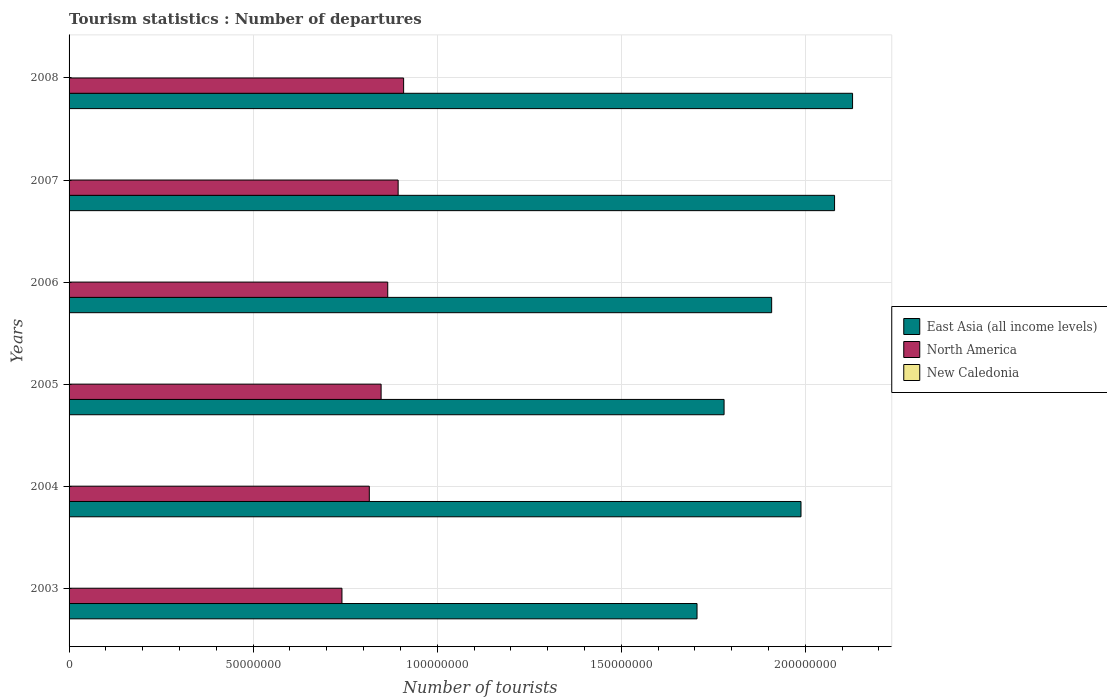How many different coloured bars are there?
Ensure brevity in your answer.  3. What is the label of the 5th group of bars from the top?
Offer a very short reply. 2004. In how many cases, is the number of bars for a given year not equal to the number of legend labels?
Provide a succinct answer. 0. What is the number of tourist departures in New Caledonia in 2004?
Ensure brevity in your answer.  8.90e+04. Across all years, what is the maximum number of tourist departures in New Caledonia?
Your answer should be compact. 1.12e+05. Across all years, what is the minimum number of tourist departures in North America?
Provide a short and direct response. 7.41e+07. What is the total number of tourist departures in North America in the graph?
Keep it short and to the point. 5.07e+08. What is the difference between the number of tourist departures in North America in 2005 and that in 2008?
Provide a short and direct response. -6.12e+06. What is the difference between the number of tourist departures in New Caledonia in 2004 and the number of tourist departures in East Asia (all income levels) in 2008?
Your answer should be very brief. -2.13e+08. What is the average number of tourist departures in New Caledonia per year?
Offer a terse response. 9.68e+04. In the year 2003, what is the difference between the number of tourist departures in East Asia (all income levels) and number of tourist departures in New Caledonia?
Provide a succinct answer. 1.71e+08. What is the ratio of the number of tourist departures in East Asia (all income levels) in 2003 to that in 2006?
Keep it short and to the point. 0.89. Is the difference between the number of tourist departures in East Asia (all income levels) in 2004 and 2008 greater than the difference between the number of tourist departures in New Caledonia in 2004 and 2008?
Offer a terse response. No. What is the difference between the highest and the second highest number of tourist departures in North America?
Provide a short and direct response. 1.49e+06. What is the difference between the highest and the lowest number of tourist departures in East Asia (all income levels)?
Keep it short and to the point. 4.23e+07. What does the 1st bar from the top in 2006 represents?
Offer a very short reply. New Caledonia. What does the 3rd bar from the bottom in 2008 represents?
Your response must be concise. New Caledonia. How many bars are there?
Provide a short and direct response. 18. Are the values on the major ticks of X-axis written in scientific E-notation?
Make the answer very short. No. Does the graph contain any zero values?
Provide a short and direct response. No. Does the graph contain grids?
Offer a very short reply. Yes. How are the legend labels stacked?
Your answer should be compact. Vertical. What is the title of the graph?
Ensure brevity in your answer.  Tourism statistics : Number of departures. What is the label or title of the X-axis?
Make the answer very short. Number of tourists. What is the label or title of the Y-axis?
Make the answer very short. Years. What is the Number of tourists of East Asia (all income levels) in 2003?
Your answer should be very brief. 1.71e+08. What is the Number of tourists of North America in 2003?
Your answer should be compact. 7.41e+07. What is the Number of tourists in New Caledonia in 2003?
Provide a succinct answer. 7.80e+04. What is the Number of tourists in East Asia (all income levels) in 2004?
Offer a terse response. 1.99e+08. What is the Number of tourists of North America in 2004?
Provide a short and direct response. 8.16e+07. What is the Number of tourists of New Caledonia in 2004?
Ensure brevity in your answer.  8.90e+04. What is the Number of tourists of East Asia (all income levels) in 2005?
Keep it short and to the point. 1.78e+08. What is the Number of tourists of North America in 2005?
Provide a succinct answer. 8.48e+07. What is the Number of tourists in New Caledonia in 2005?
Provide a short and direct response. 9.60e+04. What is the Number of tourists of East Asia (all income levels) in 2006?
Your response must be concise. 1.91e+08. What is the Number of tourists of North America in 2006?
Your response must be concise. 8.66e+07. What is the Number of tourists in East Asia (all income levels) in 2007?
Offer a very short reply. 2.08e+08. What is the Number of tourists in North America in 2007?
Provide a short and direct response. 8.94e+07. What is the Number of tourists in New Caledonia in 2007?
Ensure brevity in your answer.  1.06e+05. What is the Number of tourists of East Asia (all income levels) in 2008?
Make the answer very short. 2.13e+08. What is the Number of tourists of North America in 2008?
Offer a terse response. 9.09e+07. What is the Number of tourists in New Caledonia in 2008?
Provide a succinct answer. 1.12e+05. Across all years, what is the maximum Number of tourists of East Asia (all income levels)?
Provide a short and direct response. 2.13e+08. Across all years, what is the maximum Number of tourists of North America?
Your response must be concise. 9.09e+07. Across all years, what is the maximum Number of tourists in New Caledonia?
Your response must be concise. 1.12e+05. Across all years, what is the minimum Number of tourists in East Asia (all income levels)?
Keep it short and to the point. 1.71e+08. Across all years, what is the minimum Number of tourists of North America?
Provide a succinct answer. 7.41e+07. Across all years, what is the minimum Number of tourists in New Caledonia?
Provide a short and direct response. 7.80e+04. What is the total Number of tourists of East Asia (all income levels) in the graph?
Your answer should be compact. 1.16e+09. What is the total Number of tourists in North America in the graph?
Your answer should be very brief. 5.07e+08. What is the total Number of tourists of New Caledonia in the graph?
Keep it short and to the point. 5.81e+05. What is the difference between the Number of tourists of East Asia (all income levels) in 2003 and that in 2004?
Provide a short and direct response. -2.82e+07. What is the difference between the Number of tourists of North America in 2003 and that in 2004?
Offer a terse response. -7.43e+06. What is the difference between the Number of tourists of New Caledonia in 2003 and that in 2004?
Provide a short and direct response. -1.10e+04. What is the difference between the Number of tourists of East Asia (all income levels) in 2003 and that in 2005?
Your answer should be very brief. -7.35e+06. What is the difference between the Number of tourists of North America in 2003 and that in 2005?
Provide a short and direct response. -1.06e+07. What is the difference between the Number of tourists of New Caledonia in 2003 and that in 2005?
Offer a terse response. -1.80e+04. What is the difference between the Number of tourists of East Asia (all income levels) in 2003 and that in 2006?
Keep it short and to the point. -2.03e+07. What is the difference between the Number of tourists of North America in 2003 and that in 2006?
Keep it short and to the point. -1.24e+07. What is the difference between the Number of tourists in New Caledonia in 2003 and that in 2006?
Ensure brevity in your answer.  -2.20e+04. What is the difference between the Number of tourists in East Asia (all income levels) in 2003 and that in 2007?
Your answer should be very brief. -3.74e+07. What is the difference between the Number of tourists in North America in 2003 and that in 2007?
Offer a terse response. -1.53e+07. What is the difference between the Number of tourists of New Caledonia in 2003 and that in 2007?
Keep it short and to the point. -2.80e+04. What is the difference between the Number of tourists of East Asia (all income levels) in 2003 and that in 2008?
Offer a very short reply. -4.23e+07. What is the difference between the Number of tourists in North America in 2003 and that in 2008?
Offer a terse response. -1.67e+07. What is the difference between the Number of tourists of New Caledonia in 2003 and that in 2008?
Your response must be concise. -3.40e+04. What is the difference between the Number of tourists of East Asia (all income levels) in 2004 and that in 2005?
Offer a very short reply. 2.09e+07. What is the difference between the Number of tourists in North America in 2004 and that in 2005?
Your response must be concise. -3.20e+06. What is the difference between the Number of tourists in New Caledonia in 2004 and that in 2005?
Make the answer very short. -7000. What is the difference between the Number of tourists of East Asia (all income levels) in 2004 and that in 2006?
Give a very brief answer. 7.97e+06. What is the difference between the Number of tourists in North America in 2004 and that in 2006?
Your answer should be compact. -5.00e+06. What is the difference between the Number of tourists in New Caledonia in 2004 and that in 2006?
Give a very brief answer. -1.10e+04. What is the difference between the Number of tourists in East Asia (all income levels) in 2004 and that in 2007?
Your answer should be compact. -9.12e+06. What is the difference between the Number of tourists in North America in 2004 and that in 2007?
Ensure brevity in your answer.  -7.83e+06. What is the difference between the Number of tourists of New Caledonia in 2004 and that in 2007?
Make the answer very short. -1.70e+04. What is the difference between the Number of tourists in East Asia (all income levels) in 2004 and that in 2008?
Offer a very short reply. -1.40e+07. What is the difference between the Number of tourists in North America in 2004 and that in 2008?
Give a very brief answer. -9.32e+06. What is the difference between the Number of tourists of New Caledonia in 2004 and that in 2008?
Make the answer very short. -2.30e+04. What is the difference between the Number of tourists of East Asia (all income levels) in 2005 and that in 2006?
Provide a succinct answer. -1.29e+07. What is the difference between the Number of tourists in North America in 2005 and that in 2006?
Ensure brevity in your answer.  -1.80e+06. What is the difference between the Number of tourists in New Caledonia in 2005 and that in 2006?
Ensure brevity in your answer.  -4000. What is the difference between the Number of tourists of East Asia (all income levels) in 2005 and that in 2007?
Make the answer very short. -3.00e+07. What is the difference between the Number of tourists in North America in 2005 and that in 2007?
Your response must be concise. -4.63e+06. What is the difference between the Number of tourists of New Caledonia in 2005 and that in 2007?
Ensure brevity in your answer.  -10000. What is the difference between the Number of tourists of East Asia (all income levels) in 2005 and that in 2008?
Give a very brief answer. -3.49e+07. What is the difference between the Number of tourists in North America in 2005 and that in 2008?
Your response must be concise. -6.12e+06. What is the difference between the Number of tourists of New Caledonia in 2005 and that in 2008?
Provide a short and direct response. -1.60e+04. What is the difference between the Number of tourists of East Asia (all income levels) in 2006 and that in 2007?
Keep it short and to the point. -1.71e+07. What is the difference between the Number of tourists of North America in 2006 and that in 2007?
Make the answer very short. -2.83e+06. What is the difference between the Number of tourists in New Caledonia in 2006 and that in 2007?
Provide a succinct answer. -6000. What is the difference between the Number of tourists of East Asia (all income levels) in 2006 and that in 2008?
Give a very brief answer. -2.20e+07. What is the difference between the Number of tourists in North America in 2006 and that in 2008?
Provide a succinct answer. -4.32e+06. What is the difference between the Number of tourists of New Caledonia in 2006 and that in 2008?
Offer a terse response. -1.20e+04. What is the difference between the Number of tourists of East Asia (all income levels) in 2007 and that in 2008?
Offer a very short reply. -4.89e+06. What is the difference between the Number of tourists of North America in 2007 and that in 2008?
Keep it short and to the point. -1.49e+06. What is the difference between the Number of tourists of New Caledonia in 2007 and that in 2008?
Your response must be concise. -6000. What is the difference between the Number of tourists in East Asia (all income levels) in 2003 and the Number of tourists in North America in 2004?
Ensure brevity in your answer.  8.90e+07. What is the difference between the Number of tourists of East Asia (all income levels) in 2003 and the Number of tourists of New Caledonia in 2004?
Give a very brief answer. 1.70e+08. What is the difference between the Number of tourists in North America in 2003 and the Number of tourists in New Caledonia in 2004?
Provide a short and direct response. 7.40e+07. What is the difference between the Number of tourists of East Asia (all income levels) in 2003 and the Number of tourists of North America in 2005?
Your answer should be compact. 8.58e+07. What is the difference between the Number of tourists in East Asia (all income levels) in 2003 and the Number of tourists in New Caledonia in 2005?
Ensure brevity in your answer.  1.70e+08. What is the difference between the Number of tourists of North America in 2003 and the Number of tourists of New Caledonia in 2005?
Provide a succinct answer. 7.40e+07. What is the difference between the Number of tourists of East Asia (all income levels) in 2003 and the Number of tourists of North America in 2006?
Provide a succinct answer. 8.40e+07. What is the difference between the Number of tourists of East Asia (all income levels) in 2003 and the Number of tourists of New Caledonia in 2006?
Your response must be concise. 1.70e+08. What is the difference between the Number of tourists in North America in 2003 and the Number of tourists in New Caledonia in 2006?
Give a very brief answer. 7.40e+07. What is the difference between the Number of tourists in East Asia (all income levels) in 2003 and the Number of tourists in North America in 2007?
Offer a very short reply. 8.12e+07. What is the difference between the Number of tourists in East Asia (all income levels) in 2003 and the Number of tourists in New Caledonia in 2007?
Keep it short and to the point. 1.70e+08. What is the difference between the Number of tourists of North America in 2003 and the Number of tourists of New Caledonia in 2007?
Offer a very short reply. 7.40e+07. What is the difference between the Number of tourists of East Asia (all income levels) in 2003 and the Number of tourists of North America in 2008?
Give a very brief answer. 7.97e+07. What is the difference between the Number of tourists in East Asia (all income levels) in 2003 and the Number of tourists in New Caledonia in 2008?
Keep it short and to the point. 1.70e+08. What is the difference between the Number of tourists of North America in 2003 and the Number of tourists of New Caledonia in 2008?
Provide a short and direct response. 7.40e+07. What is the difference between the Number of tourists of East Asia (all income levels) in 2004 and the Number of tourists of North America in 2005?
Keep it short and to the point. 1.14e+08. What is the difference between the Number of tourists of East Asia (all income levels) in 2004 and the Number of tourists of New Caledonia in 2005?
Your answer should be very brief. 1.99e+08. What is the difference between the Number of tourists in North America in 2004 and the Number of tourists in New Caledonia in 2005?
Your answer should be very brief. 8.15e+07. What is the difference between the Number of tourists of East Asia (all income levels) in 2004 and the Number of tourists of North America in 2006?
Provide a succinct answer. 1.12e+08. What is the difference between the Number of tourists of East Asia (all income levels) in 2004 and the Number of tourists of New Caledonia in 2006?
Provide a short and direct response. 1.99e+08. What is the difference between the Number of tourists of North America in 2004 and the Number of tourists of New Caledonia in 2006?
Your response must be concise. 8.15e+07. What is the difference between the Number of tourists of East Asia (all income levels) in 2004 and the Number of tourists of North America in 2007?
Offer a terse response. 1.09e+08. What is the difference between the Number of tourists of East Asia (all income levels) in 2004 and the Number of tourists of New Caledonia in 2007?
Make the answer very short. 1.99e+08. What is the difference between the Number of tourists of North America in 2004 and the Number of tourists of New Caledonia in 2007?
Your answer should be compact. 8.15e+07. What is the difference between the Number of tourists of East Asia (all income levels) in 2004 and the Number of tourists of North America in 2008?
Your response must be concise. 1.08e+08. What is the difference between the Number of tourists in East Asia (all income levels) in 2004 and the Number of tourists in New Caledonia in 2008?
Your answer should be compact. 1.99e+08. What is the difference between the Number of tourists in North America in 2004 and the Number of tourists in New Caledonia in 2008?
Your answer should be very brief. 8.14e+07. What is the difference between the Number of tourists of East Asia (all income levels) in 2005 and the Number of tourists of North America in 2006?
Provide a succinct answer. 9.14e+07. What is the difference between the Number of tourists of East Asia (all income levels) in 2005 and the Number of tourists of New Caledonia in 2006?
Offer a terse response. 1.78e+08. What is the difference between the Number of tourists in North America in 2005 and the Number of tourists in New Caledonia in 2006?
Provide a short and direct response. 8.47e+07. What is the difference between the Number of tourists in East Asia (all income levels) in 2005 and the Number of tourists in North America in 2007?
Your answer should be compact. 8.85e+07. What is the difference between the Number of tourists of East Asia (all income levels) in 2005 and the Number of tourists of New Caledonia in 2007?
Give a very brief answer. 1.78e+08. What is the difference between the Number of tourists in North America in 2005 and the Number of tourists in New Caledonia in 2007?
Your response must be concise. 8.47e+07. What is the difference between the Number of tourists in East Asia (all income levels) in 2005 and the Number of tourists in North America in 2008?
Your response must be concise. 8.71e+07. What is the difference between the Number of tourists in East Asia (all income levels) in 2005 and the Number of tourists in New Caledonia in 2008?
Provide a succinct answer. 1.78e+08. What is the difference between the Number of tourists in North America in 2005 and the Number of tourists in New Caledonia in 2008?
Ensure brevity in your answer.  8.47e+07. What is the difference between the Number of tourists in East Asia (all income levels) in 2006 and the Number of tourists in North America in 2007?
Offer a terse response. 1.01e+08. What is the difference between the Number of tourists of East Asia (all income levels) in 2006 and the Number of tourists of New Caledonia in 2007?
Offer a terse response. 1.91e+08. What is the difference between the Number of tourists in North America in 2006 and the Number of tourists in New Caledonia in 2007?
Provide a succinct answer. 8.65e+07. What is the difference between the Number of tourists in East Asia (all income levels) in 2006 and the Number of tourists in North America in 2008?
Your answer should be compact. 1.00e+08. What is the difference between the Number of tourists of East Asia (all income levels) in 2006 and the Number of tourists of New Caledonia in 2008?
Make the answer very short. 1.91e+08. What is the difference between the Number of tourists of North America in 2006 and the Number of tourists of New Caledonia in 2008?
Offer a terse response. 8.65e+07. What is the difference between the Number of tourists of East Asia (all income levels) in 2007 and the Number of tourists of North America in 2008?
Your response must be concise. 1.17e+08. What is the difference between the Number of tourists in East Asia (all income levels) in 2007 and the Number of tourists in New Caledonia in 2008?
Provide a short and direct response. 2.08e+08. What is the difference between the Number of tourists in North America in 2007 and the Number of tourists in New Caledonia in 2008?
Offer a very short reply. 8.93e+07. What is the average Number of tourists in East Asia (all income levels) per year?
Offer a terse response. 1.93e+08. What is the average Number of tourists in North America per year?
Ensure brevity in your answer.  8.45e+07. What is the average Number of tourists in New Caledonia per year?
Your response must be concise. 9.68e+04. In the year 2003, what is the difference between the Number of tourists in East Asia (all income levels) and Number of tourists in North America?
Your response must be concise. 9.65e+07. In the year 2003, what is the difference between the Number of tourists in East Asia (all income levels) and Number of tourists in New Caledonia?
Your response must be concise. 1.71e+08. In the year 2003, what is the difference between the Number of tourists of North America and Number of tourists of New Caledonia?
Your answer should be very brief. 7.41e+07. In the year 2004, what is the difference between the Number of tourists in East Asia (all income levels) and Number of tourists in North America?
Offer a very short reply. 1.17e+08. In the year 2004, what is the difference between the Number of tourists in East Asia (all income levels) and Number of tourists in New Caledonia?
Offer a terse response. 1.99e+08. In the year 2004, what is the difference between the Number of tourists in North America and Number of tourists in New Caledonia?
Make the answer very short. 8.15e+07. In the year 2005, what is the difference between the Number of tourists of East Asia (all income levels) and Number of tourists of North America?
Offer a terse response. 9.32e+07. In the year 2005, what is the difference between the Number of tourists in East Asia (all income levels) and Number of tourists in New Caledonia?
Your answer should be very brief. 1.78e+08. In the year 2005, what is the difference between the Number of tourists in North America and Number of tourists in New Caledonia?
Your answer should be compact. 8.47e+07. In the year 2006, what is the difference between the Number of tourists in East Asia (all income levels) and Number of tourists in North America?
Give a very brief answer. 1.04e+08. In the year 2006, what is the difference between the Number of tourists of East Asia (all income levels) and Number of tourists of New Caledonia?
Make the answer very short. 1.91e+08. In the year 2006, what is the difference between the Number of tourists of North America and Number of tourists of New Caledonia?
Offer a very short reply. 8.65e+07. In the year 2007, what is the difference between the Number of tourists in East Asia (all income levels) and Number of tourists in North America?
Provide a short and direct response. 1.19e+08. In the year 2007, what is the difference between the Number of tourists of East Asia (all income levels) and Number of tourists of New Caledonia?
Offer a terse response. 2.08e+08. In the year 2007, what is the difference between the Number of tourists in North America and Number of tourists in New Caledonia?
Provide a short and direct response. 8.93e+07. In the year 2008, what is the difference between the Number of tourists of East Asia (all income levels) and Number of tourists of North America?
Provide a succinct answer. 1.22e+08. In the year 2008, what is the difference between the Number of tourists in East Asia (all income levels) and Number of tourists in New Caledonia?
Ensure brevity in your answer.  2.13e+08. In the year 2008, what is the difference between the Number of tourists of North America and Number of tourists of New Caledonia?
Your response must be concise. 9.08e+07. What is the ratio of the Number of tourists of East Asia (all income levels) in 2003 to that in 2004?
Your response must be concise. 0.86. What is the ratio of the Number of tourists of North America in 2003 to that in 2004?
Ensure brevity in your answer.  0.91. What is the ratio of the Number of tourists of New Caledonia in 2003 to that in 2004?
Ensure brevity in your answer.  0.88. What is the ratio of the Number of tourists in East Asia (all income levels) in 2003 to that in 2005?
Your answer should be compact. 0.96. What is the ratio of the Number of tourists of North America in 2003 to that in 2005?
Give a very brief answer. 0.87. What is the ratio of the Number of tourists of New Caledonia in 2003 to that in 2005?
Provide a short and direct response. 0.81. What is the ratio of the Number of tourists in East Asia (all income levels) in 2003 to that in 2006?
Offer a terse response. 0.89. What is the ratio of the Number of tourists of North America in 2003 to that in 2006?
Provide a short and direct response. 0.86. What is the ratio of the Number of tourists in New Caledonia in 2003 to that in 2006?
Provide a short and direct response. 0.78. What is the ratio of the Number of tourists in East Asia (all income levels) in 2003 to that in 2007?
Keep it short and to the point. 0.82. What is the ratio of the Number of tourists of North America in 2003 to that in 2007?
Provide a succinct answer. 0.83. What is the ratio of the Number of tourists in New Caledonia in 2003 to that in 2007?
Your answer should be very brief. 0.74. What is the ratio of the Number of tourists in East Asia (all income levels) in 2003 to that in 2008?
Your answer should be very brief. 0.8. What is the ratio of the Number of tourists of North America in 2003 to that in 2008?
Provide a short and direct response. 0.82. What is the ratio of the Number of tourists of New Caledonia in 2003 to that in 2008?
Provide a succinct answer. 0.7. What is the ratio of the Number of tourists of East Asia (all income levels) in 2004 to that in 2005?
Offer a very short reply. 1.12. What is the ratio of the Number of tourists of North America in 2004 to that in 2005?
Your answer should be compact. 0.96. What is the ratio of the Number of tourists in New Caledonia in 2004 to that in 2005?
Provide a short and direct response. 0.93. What is the ratio of the Number of tourists of East Asia (all income levels) in 2004 to that in 2006?
Give a very brief answer. 1.04. What is the ratio of the Number of tourists in North America in 2004 to that in 2006?
Offer a very short reply. 0.94. What is the ratio of the Number of tourists in New Caledonia in 2004 to that in 2006?
Your answer should be compact. 0.89. What is the ratio of the Number of tourists of East Asia (all income levels) in 2004 to that in 2007?
Your response must be concise. 0.96. What is the ratio of the Number of tourists in North America in 2004 to that in 2007?
Your response must be concise. 0.91. What is the ratio of the Number of tourists in New Caledonia in 2004 to that in 2007?
Provide a short and direct response. 0.84. What is the ratio of the Number of tourists of East Asia (all income levels) in 2004 to that in 2008?
Keep it short and to the point. 0.93. What is the ratio of the Number of tourists of North America in 2004 to that in 2008?
Provide a short and direct response. 0.9. What is the ratio of the Number of tourists of New Caledonia in 2004 to that in 2008?
Provide a short and direct response. 0.79. What is the ratio of the Number of tourists of East Asia (all income levels) in 2005 to that in 2006?
Ensure brevity in your answer.  0.93. What is the ratio of the Number of tourists of North America in 2005 to that in 2006?
Your response must be concise. 0.98. What is the ratio of the Number of tourists of New Caledonia in 2005 to that in 2006?
Your answer should be very brief. 0.96. What is the ratio of the Number of tourists of East Asia (all income levels) in 2005 to that in 2007?
Make the answer very short. 0.86. What is the ratio of the Number of tourists in North America in 2005 to that in 2007?
Keep it short and to the point. 0.95. What is the ratio of the Number of tourists in New Caledonia in 2005 to that in 2007?
Your answer should be compact. 0.91. What is the ratio of the Number of tourists of East Asia (all income levels) in 2005 to that in 2008?
Your response must be concise. 0.84. What is the ratio of the Number of tourists of North America in 2005 to that in 2008?
Offer a terse response. 0.93. What is the ratio of the Number of tourists in East Asia (all income levels) in 2006 to that in 2007?
Ensure brevity in your answer.  0.92. What is the ratio of the Number of tourists in North America in 2006 to that in 2007?
Keep it short and to the point. 0.97. What is the ratio of the Number of tourists in New Caledonia in 2006 to that in 2007?
Your answer should be compact. 0.94. What is the ratio of the Number of tourists in East Asia (all income levels) in 2006 to that in 2008?
Offer a very short reply. 0.9. What is the ratio of the Number of tourists in North America in 2006 to that in 2008?
Your answer should be very brief. 0.95. What is the ratio of the Number of tourists of New Caledonia in 2006 to that in 2008?
Provide a succinct answer. 0.89. What is the ratio of the Number of tourists of East Asia (all income levels) in 2007 to that in 2008?
Your answer should be compact. 0.98. What is the ratio of the Number of tourists of North America in 2007 to that in 2008?
Ensure brevity in your answer.  0.98. What is the ratio of the Number of tourists in New Caledonia in 2007 to that in 2008?
Ensure brevity in your answer.  0.95. What is the difference between the highest and the second highest Number of tourists in East Asia (all income levels)?
Your answer should be compact. 4.89e+06. What is the difference between the highest and the second highest Number of tourists of North America?
Your response must be concise. 1.49e+06. What is the difference between the highest and the second highest Number of tourists of New Caledonia?
Provide a short and direct response. 6000. What is the difference between the highest and the lowest Number of tourists of East Asia (all income levels)?
Make the answer very short. 4.23e+07. What is the difference between the highest and the lowest Number of tourists in North America?
Offer a terse response. 1.67e+07. What is the difference between the highest and the lowest Number of tourists in New Caledonia?
Offer a terse response. 3.40e+04. 